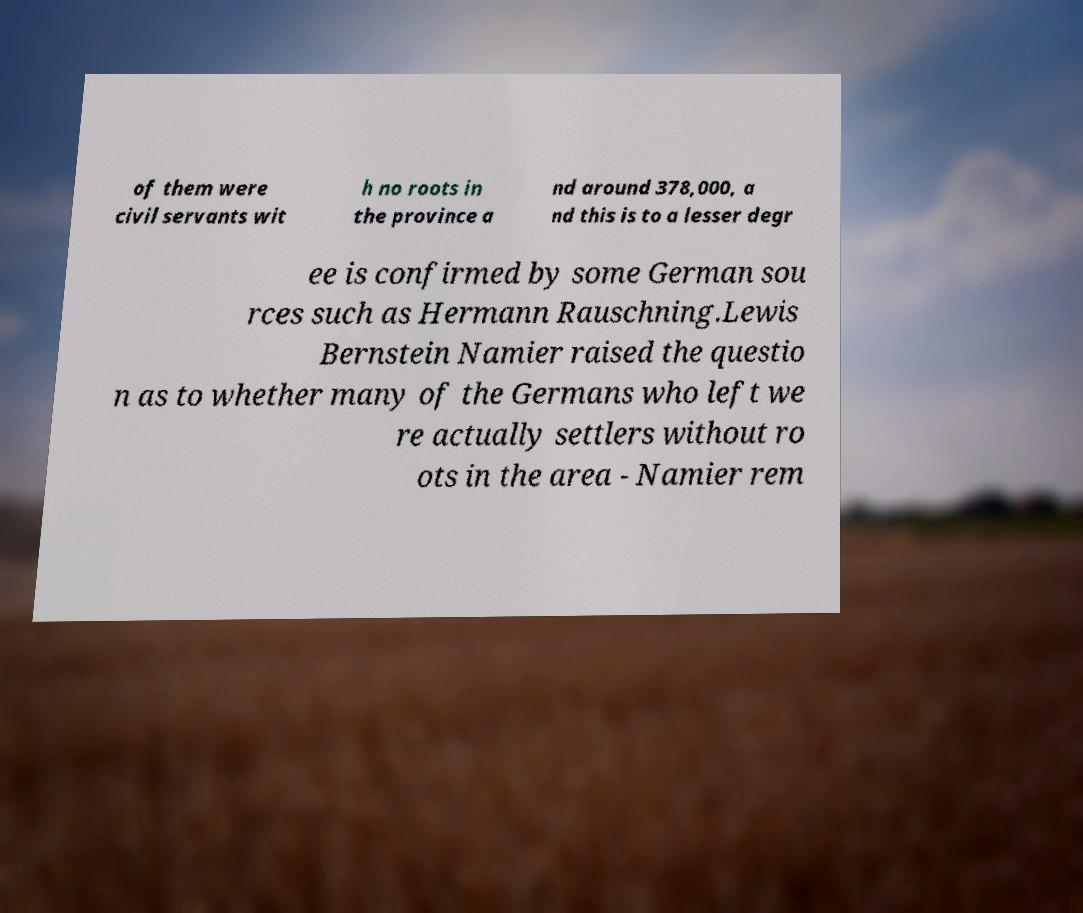Can you read and provide the text displayed in the image?This photo seems to have some interesting text. Can you extract and type it out for me? of them were civil servants wit h no roots in the province a nd around 378,000, a nd this is to a lesser degr ee is confirmed by some German sou rces such as Hermann Rauschning.Lewis Bernstein Namier raised the questio n as to whether many of the Germans who left we re actually settlers without ro ots in the area - Namier rem 